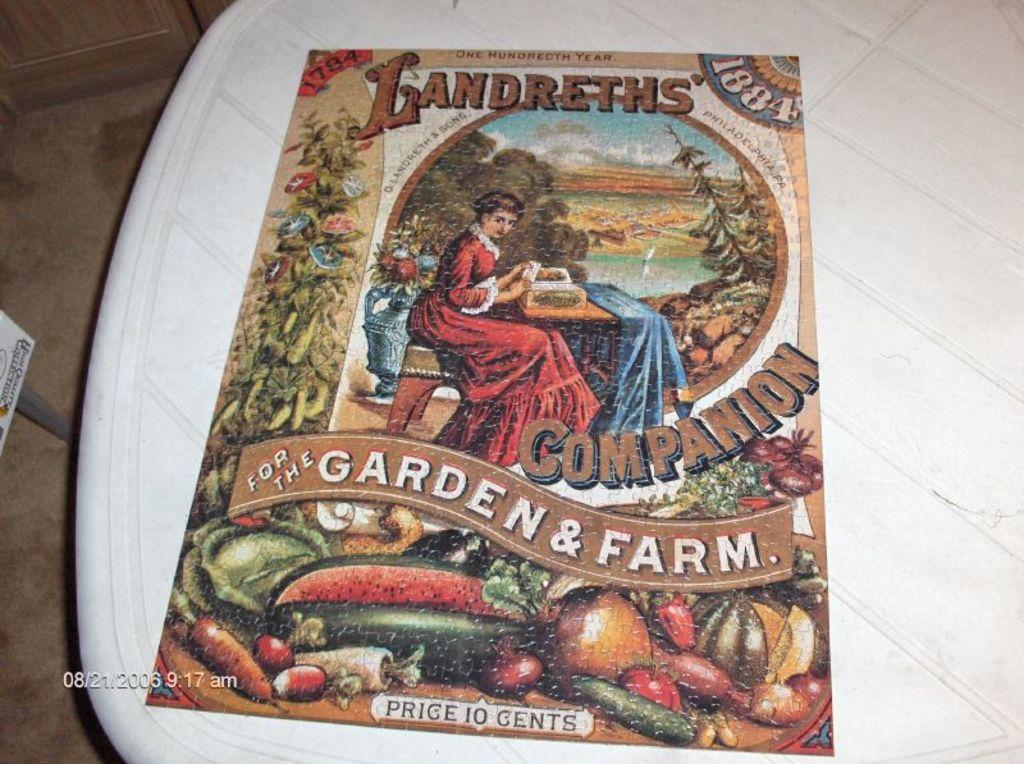<image>
Give a short and clear explanation of the subsequent image. Vintage Landreths Companion magazine for the Garden & Farm price 10cents. 